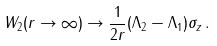Convert formula to latex. <formula><loc_0><loc_0><loc_500><loc_500>W _ { 2 } ( r \to \infty ) \to \frac { 1 } { 2 r } ( \Lambda _ { 2 } - \Lambda _ { 1 } ) \sigma _ { z } \, .</formula> 